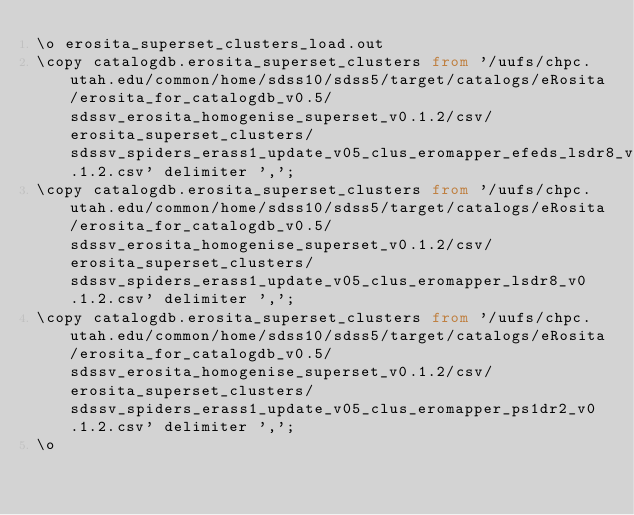Convert code to text. <code><loc_0><loc_0><loc_500><loc_500><_SQL_>\o erosita_superset_clusters_load.out
\copy catalogdb.erosita_superset_clusters from '/uufs/chpc.utah.edu/common/home/sdss10/sdss5/target/catalogs/eRosita/erosita_for_catalogdb_v0.5/sdssv_erosita_homogenise_superset_v0.1.2/csv/erosita_superset_clusters/sdssv_spiders_erass1_update_v05_clus_eromapper_efeds_lsdr8_v0.1.2.csv' delimiter ',';
\copy catalogdb.erosita_superset_clusters from '/uufs/chpc.utah.edu/common/home/sdss10/sdss5/target/catalogs/eRosita/erosita_for_catalogdb_v0.5/sdssv_erosita_homogenise_superset_v0.1.2/csv/erosita_superset_clusters/sdssv_spiders_erass1_update_v05_clus_eromapper_lsdr8_v0.1.2.csv' delimiter ',';
\copy catalogdb.erosita_superset_clusters from '/uufs/chpc.utah.edu/common/home/sdss10/sdss5/target/catalogs/eRosita/erosita_for_catalogdb_v0.5/sdssv_erosita_homogenise_superset_v0.1.2/csv/erosita_superset_clusters/sdssv_spiders_erass1_update_v05_clus_eromapper_ps1dr2_v0.1.2.csv' delimiter ',';
\o
</code> 